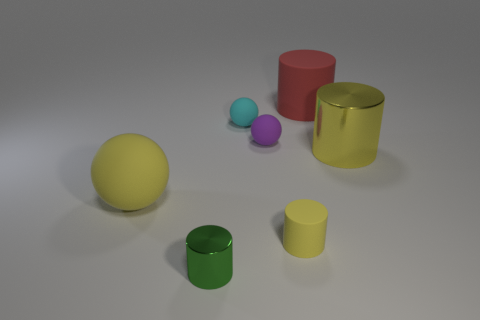What color is the big object that is both in front of the big red matte cylinder and on the right side of the big yellow ball?
Give a very brief answer. Yellow. What number of other objects are there of the same size as the red thing?
Offer a terse response. 2. Is the size of the red rubber cylinder the same as the yellow thing behind the big rubber ball?
Your response must be concise. Yes. There is a cylinder that is the same size as the green thing; what color is it?
Offer a very short reply. Yellow. How big is the cyan matte thing?
Provide a succinct answer. Small. Are the yellow cylinder on the left side of the large yellow metallic cylinder and the green cylinder made of the same material?
Offer a terse response. No. Is the shape of the green shiny object the same as the big yellow shiny object?
Offer a terse response. Yes. There is a yellow thing that is on the right side of the small yellow cylinder in front of the thing on the right side of the red cylinder; what is its shape?
Your response must be concise. Cylinder. Is the shape of the big object that is behind the cyan sphere the same as the yellow object to the right of the small yellow matte cylinder?
Keep it short and to the point. Yes. Are there any large brown balls that have the same material as the large yellow cylinder?
Offer a very short reply. No. 